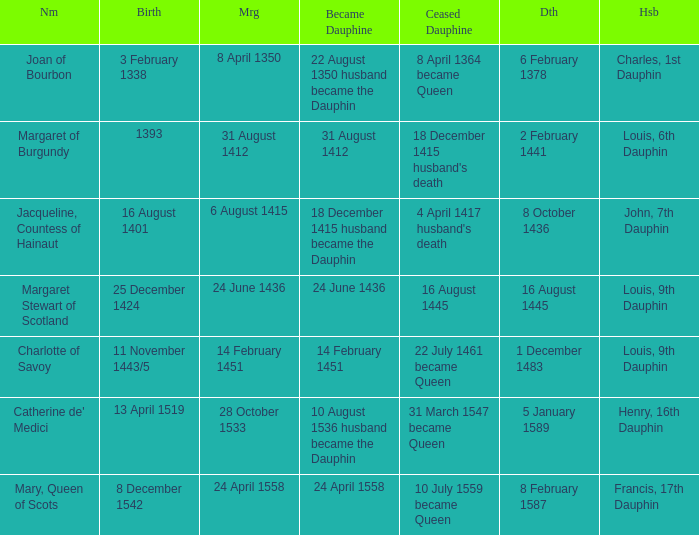When was the death when the birth was 8 december 1542? 8 February 1587. 